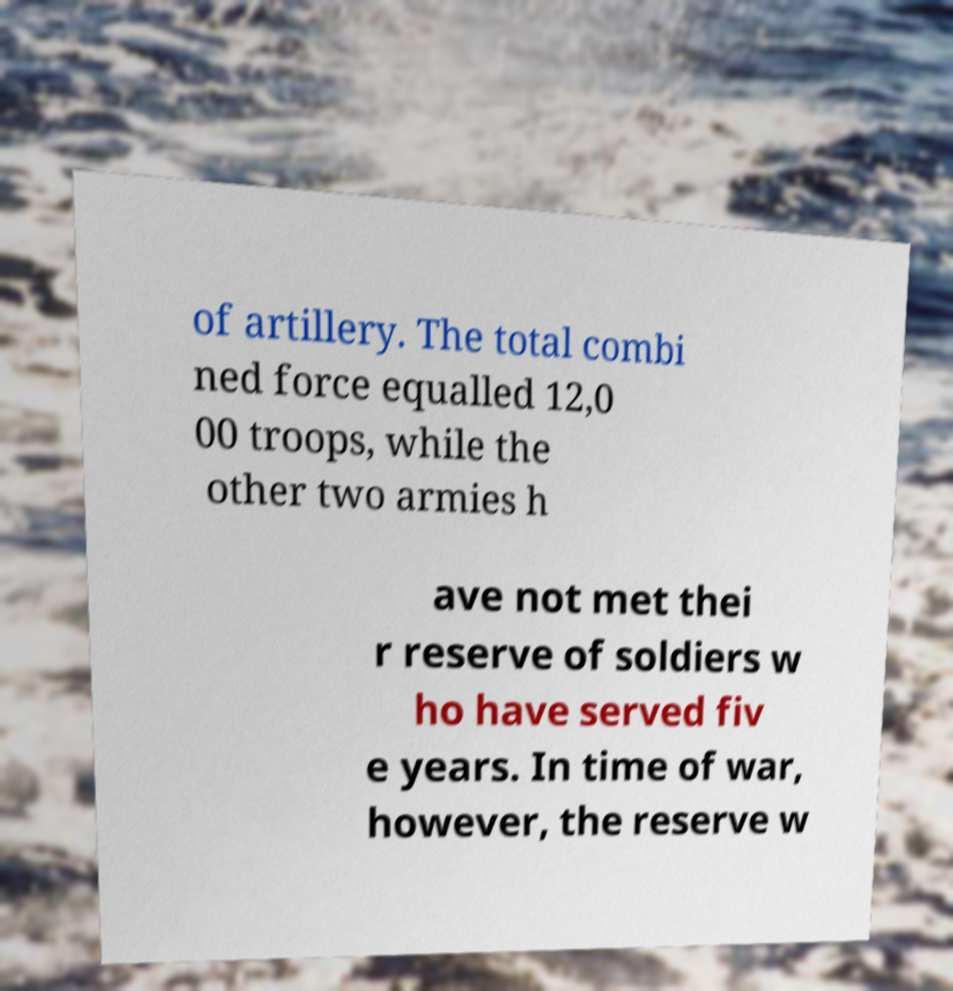Please identify and transcribe the text found in this image. of artillery. The total combi ned force equalled 12,0 00 troops, while the other two armies h ave not met thei r reserve of soldiers w ho have served fiv e years. In time of war, however, the reserve w 